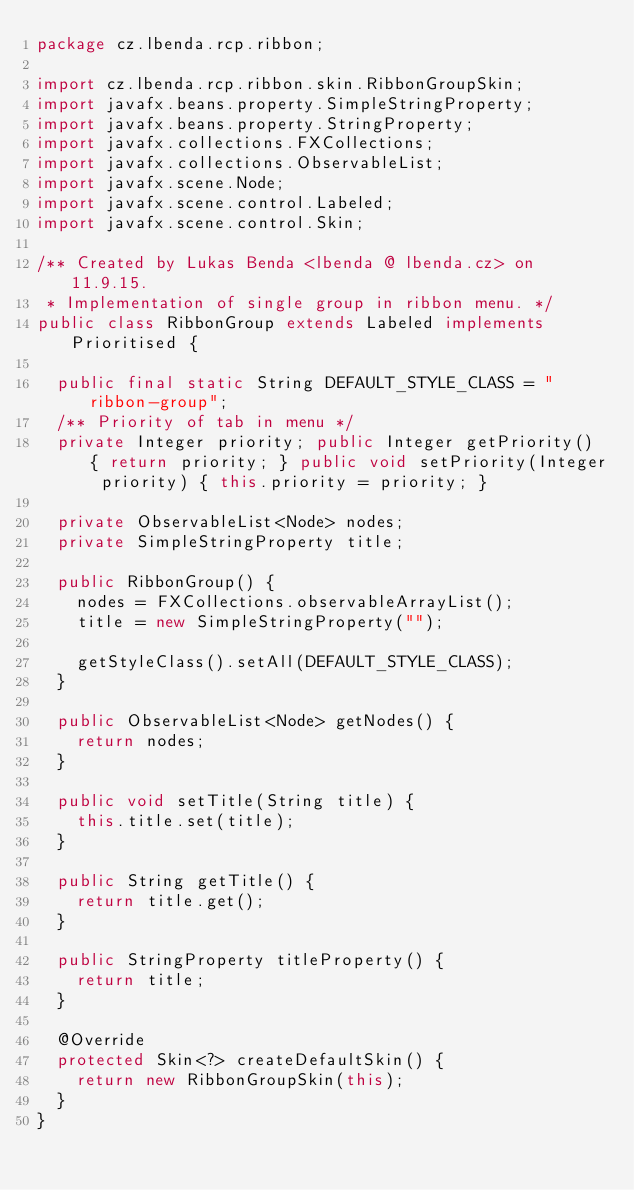Convert code to text. <code><loc_0><loc_0><loc_500><loc_500><_Java_>package cz.lbenda.rcp.ribbon;

import cz.lbenda.rcp.ribbon.skin.RibbonGroupSkin;
import javafx.beans.property.SimpleStringProperty;
import javafx.beans.property.StringProperty;
import javafx.collections.FXCollections;
import javafx.collections.ObservableList;
import javafx.scene.Node;
import javafx.scene.control.Labeled;
import javafx.scene.control.Skin;

/** Created by Lukas Benda <lbenda @ lbenda.cz> on 11.9.15.
 * Implementation of single group in ribbon menu. */
public class RibbonGroup extends Labeled implements Prioritised {

  public final static String DEFAULT_STYLE_CLASS = "ribbon-group";
  /** Priority of tab in menu */
  private Integer priority; public Integer getPriority() { return priority; } public void setPriority(Integer priority) { this.priority = priority; }

  private ObservableList<Node> nodes;
  private SimpleStringProperty title;

  public RibbonGroup() {
    nodes = FXCollections.observableArrayList();
    title = new SimpleStringProperty("");

    getStyleClass().setAll(DEFAULT_STYLE_CLASS);
  }

  public ObservableList<Node> getNodes() {
    return nodes;
  }

  public void setTitle(String title) {
    this.title.set(title);
  }

  public String getTitle() {
    return title.get();
  }

  public StringProperty titleProperty() {
    return title;
  }

  @Override
  protected Skin<?> createDefaultSkin() {
    return new RibbonGroupSkin(this);
  }
}
</code> 